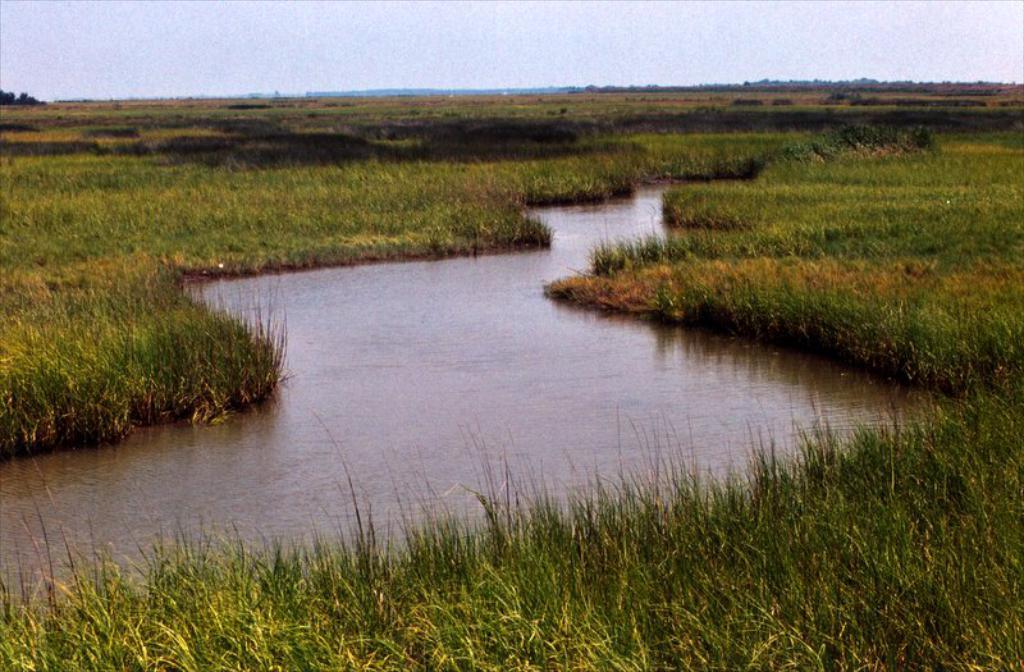What type of vegetation is present in the image? There is grass in the image. What else can be seen in the image besides grass? There is water in the image. What is visible in the background of the image? The sky is visible in the background of the image. How would you describe the weather based on the sky in the image? The sky is clear, which suggests good weather. What type of whip can be seen in the image? There is no whip present in the image. What sign is visible in the image? There is no sign visible in the image. 